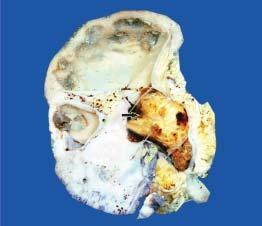what is with chronic pyelonephritis?
Answer the question using a single word or phrase. Taghorn renal stone 